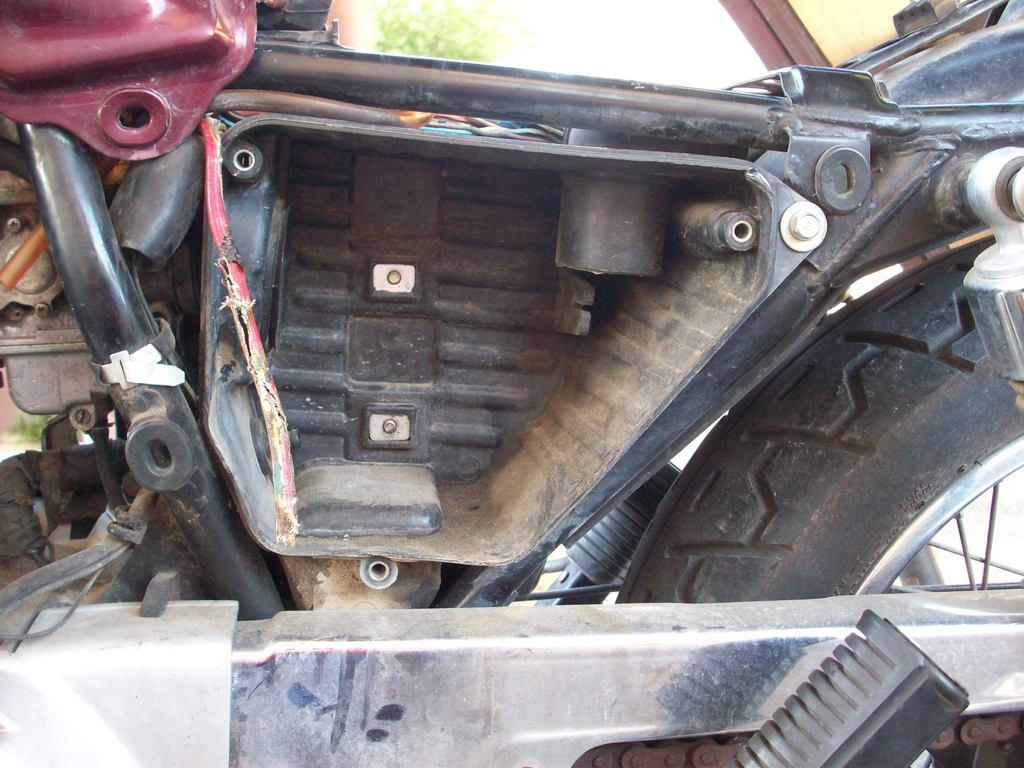What type of setting is depicted in the image? The image shows the inside part of a vehicle. Can you describe any elements visible outside the vehicle? There is a tree visible in the background of the image. What type of butter can be seen melting on the airplane in the image? There is no butter or airplane present in the image; it shows the inside part of a vehicle with a tree visible in the background. 